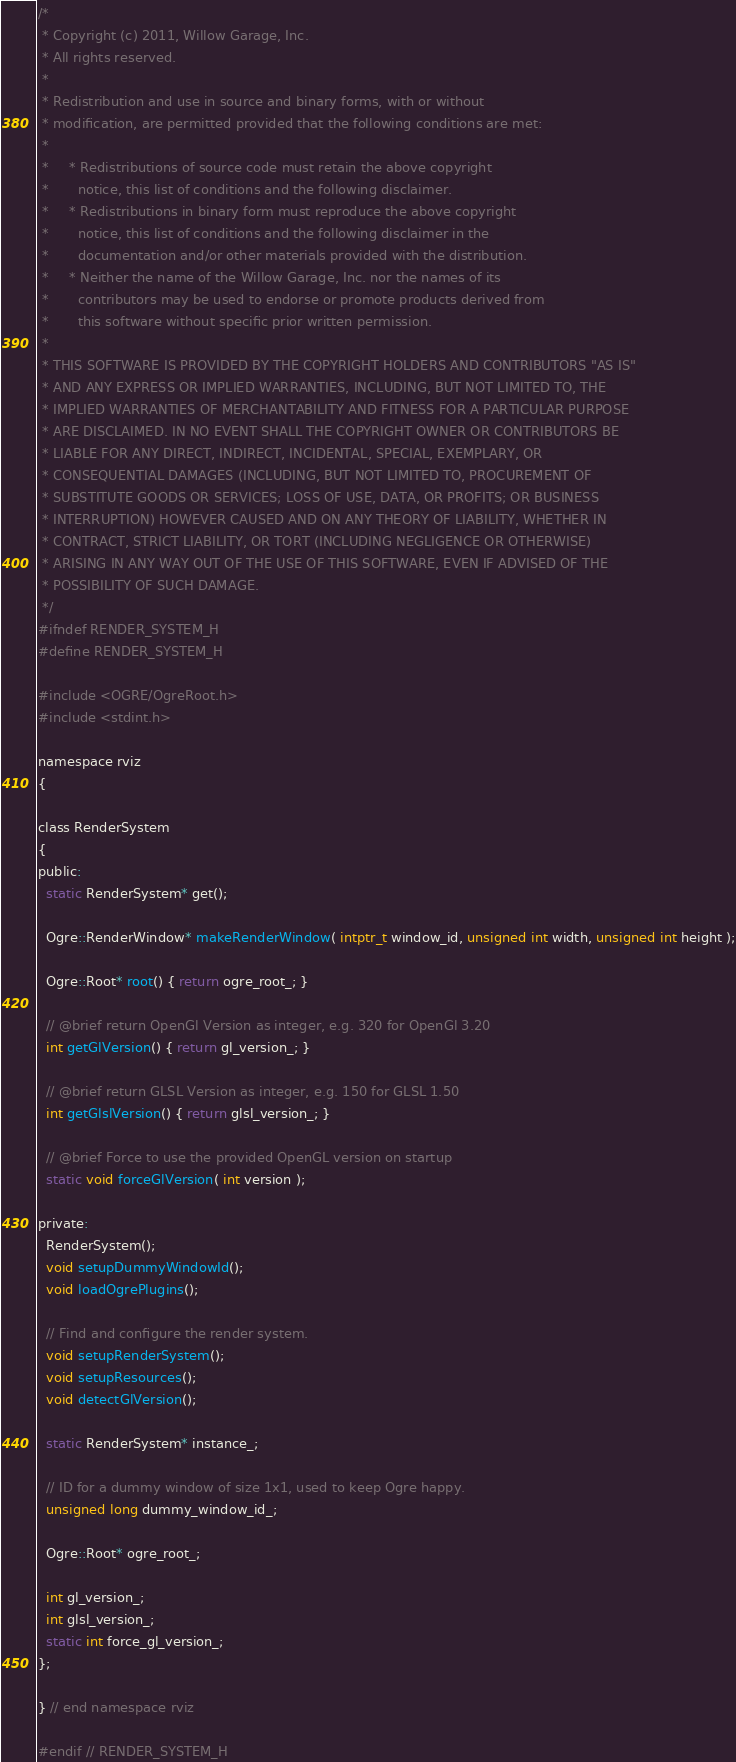<code> <loc_0><loc_0><loc_500><loc_500><_C_>/*
 * Copyright (c) 2011, Willow Garage, Inc.
 * All rights reserved.
 *
 * Redistribution and use in source and binary forms, with or without
 * modification, are permitted provided that the following conditions are met:
 *
 *     * Redistributions of source code must retain the above copyright
 *       notice, this list of conditions and the following disclaimer.
 *     * Redistributions in binary form must reproduce the above copyright
 *       notice, this list of conditions and the following disclaimer in the
 *       documentation and/or other materials provided with the distribution.
 *     * Neither the name of the Willow Garage, Inc. nor the names of its
 *       contributors may be used to endorse or promote products derived from
 *       this software without specific prior written permission.
 *
 * THIS SOFTWARE IS PROVIDED BY THE COPYRIGHT HOLDERS AND CONTRIBUTORS "AS IS"
 * AND ANY EXPRESS OR IMPLIED WARRANTIES, INCLUDING, BUT NOT LIMITED TO, THE
 * IMPLIED WARRANTIES OF MERCHANTABILITY AND FITNESS FOR A PARTICULAR PURPOSE
 * ARE DISCLAIMED. IN NO EVENT SHALL THE COPYRIGHT OWNER OR CONTRIBUTORS BE
 * LIABLE FOR ANY DIRECT, INDIRECT, INCIDENTAL, SPECIAL, EXEMPLARY, OR
 * CONSEQUENTIAL DAMAGES (INCLUDING, BUT NOT LIMITED TO, PROCUREMENT OF
 * SUBSTITUTE GOODS OR SERVICES; LOSS OF USE, DATA, OR PROFITS; OR BUSINESS
 * INTERRUPTION) HOWEVER CAUSED AND ON ANY THEORY OF LIABILITY, WHETHER IN
 * CONTRACT, STRICT LIABILITY, OR TORT (INCLUDING NEGLIGENCE OR OTHERWISE)
 * ARISING IN ANY WAY OUT OF THE USE OF THIS SOFTWARE, EVEN IF ADVISED OF THE
 * POSSIBILITY OF SUCH DAMAGE.
 */
#ifndef RENDER_SYSTEM_H
#define RENDER_SYSTEM_H

#include <OGRE/OgreRoot.h>
#include <stdint.h>

namespace rviz
{

class RenderSystem
{
public:
  static RenderSystem* get();

  Ogre::RenderWindow* makeRenderWindow( intptr_t window_id, unsigned int width, unsigned int height );

  Ogre::Root* root() { return ogre_root_; }

  // @brief return OpenGl Version as integer, e.g. 320 for OpenGl 3.20
  int getGlVersion() { return gl_version_; }

  // @brief return GLSL Version as integer, e.g. 150 for GLSL 1.50
  int getGlslVersion() { return glsl_version_; }

  // @brief Force to use the provided OpenGL version on startup
  static void forceGlVersion( int version );

private:
  RenderSystem();
  void setupDummyWindowId();
  void loadOgrePlugins();

  // Find and configure the render system.
  void setupRenderSystem();
  void setupResources();
  void detectGlVersion();

  static RenderSystem* instance_;

  // ID for a dummy window of size 1x1, used to keep Ogre happy.
  unsigned long dummy_window_id_;

  Ogre::Root* ogre_root_;

  int gl_version_;
  int glsl_version_;
  static int force_gl_version_;
};

} // end namespace rviz

#endif // RENDER_SYSTEM_H
</code> 